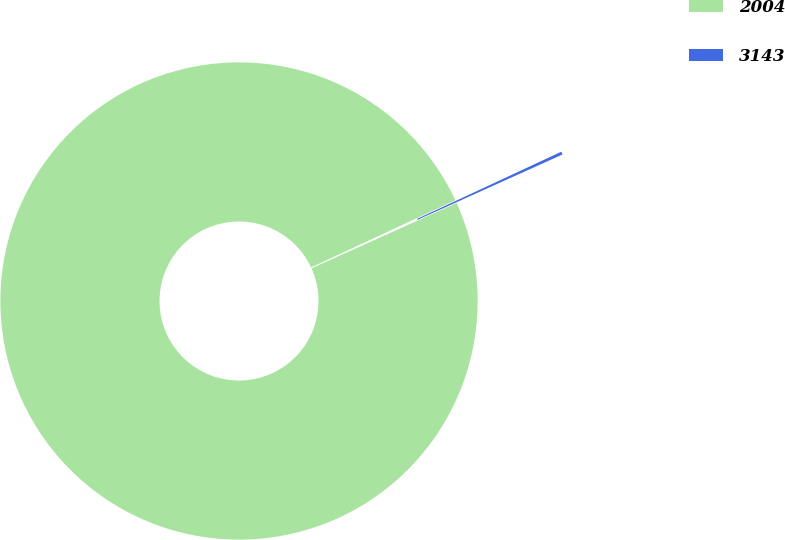Convert chart. <chart><loc_0><loc_0><loc_500><loc_500><pie_chart><fcel>2004<fcel>3143<nl><fcel>99.8%<fcel>0.2%<nl></chart> 